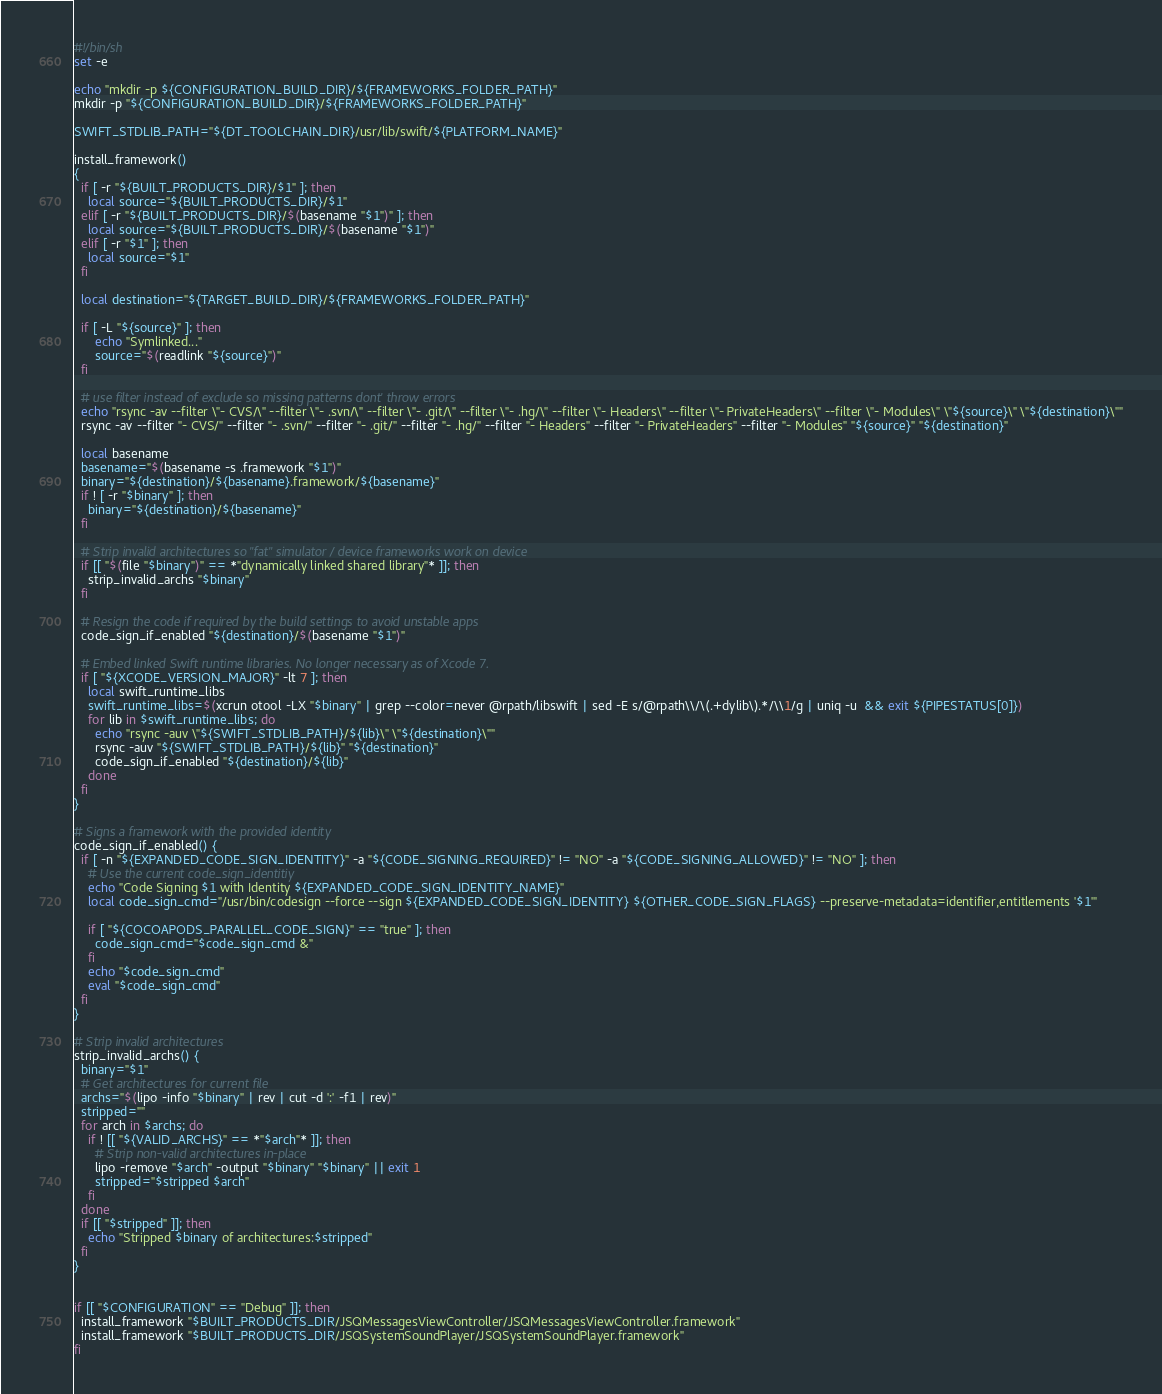<code> <loc_0><loc_0><loc_500><loc_500><_Bash_>#!/bin/sh
set -e

echo "mkdir -p ${CONFIGURATION_BUILD_DIR}/${FRAMEWORKS_FOLDER_PATH}"
mkdir -p "${CONFIGURATION_BUILD_DIR}/${FRAMEWORKS_FOLDER_PATH}"

SWIFT_STDLIB_PATH="${DT_TOOLCHAIN_DIR}/usr/lib/swift/${PLATFORM_NAME}"

install_framework()
{
  if [ -r "${BUILT_PRODUCTS_DIR}/$1" ]; then
    local source="${BUILT_PRODUCTS_DIR}/$1"
  elif [ -r "${BUILT_PRODUCTS_DIR}/$(basename "$1")" ]; then
    local source="${BUILT_PRODUCTS_DIR}/$(basename "$1")"
  elif [ -r "$1" ]; then
    local source="$1"
  fi

  local destination="${TARGET_BUILD_DIR}/${FRAMEWORKS_FOLDER_PATH}"

  if [ -L "${source}" ]; then
      echo "Symlinked..."
      source="$(readlink "${source}")"
  fi

  # use filter instead of exclude so missing patterns dont' throw errors
  echo "rsync -av --filter \"- CVS/\" --filter \"- .svn/\" --filter \"- .git/\" --filter \"- .hg/\" --filter \"- Headers\" --filter \"- PrivateHeaders\" --filter \"- Modules\" \"${source}\" \"${destination}\""
  rsync -av --filter "- CVS/" --filter "- .svn/" --filter "- .git/" --filter "- .hg/" --filter "- Headers" --filter "- PrivateHeaders" --filter "- Modules" "${source}" "${destination}"

  local basename
  basename="$(basename -s .framework "$1")"
  binary="${destination}/${basename}.framework/${basename}"
  if ! [ -r "$binary" ]; then
    binary="${destination}/${basename}"
  fi

  # Strip invalid architectures so "fat" simulator / device frameworks work on device
  if [[ "$(file "$binary")" == *"dynamically linked shared library"* ]]; then
    strip_invalid_archs "$binary"
  fi

  # Resign the code if required by the build settings to avoid unstable apps
  code_sign_if_enabled "${destination}/$(basename "$1")"

  # Embed linked Swift runtime libraries. No longer necessary as of Xcode 7.
  if [ "${XCODE_VERSION_MAJOR}" -lt 7 ]; then
    local swift_runtime_libs
    swift_runtime_libs=$(xcrun otool -LX "$binary" | grep --color=never @rpath/libswift | sed -E s/@rpath\\/\(.+dylib\).*/\\1/g | uniq -u  && exit ${PIPESTATUS[0]})
    for lib in $swift_runtime_libs; do
      echo "rsync -auv \"${SWIFT_STDLIB_PATH}/${lib}\" \"${destination}\""
      rsync -auv "${SWIFT_STDLIB_PATH}/${lib}" "${destination}"
      code_sign_if_enabled "${destination}/${lib}"
    done
  fi
}

# Signs a framework with the provided identity
code_sign_if_enabled() {
  if [ -n "${EXPANDED_CODE_SIGN_IDENTITY}" -a "${CODE_SIGNING_REQUIRED}" != "NO" -a "${CODE_SIGNING_ALLOWED}" != "NO" ]; then
    # Use the current code_sign_identitiy
    echo "Code Signing $1 with Identity ${EXPANDED_CODE_SIGN_IDENTITY_NAME}"
    local code_sign_cmd="/usr/bin/codesign --force --sign ${EXPANDED_CODE_SIGN_IDENTITY} ${OTHER_CODE_SIGN_FLAGS} --preserve-metadata=identifier,entitlements '$1'"

    if [ "${COCOAPODS_PARALLEL_CODE_SIGN}" == "true" ]; then
      code_sign_cmd="$code_sign_cmd &"
    fi
    echo "$code_sign_cmd"
    eval "$code_sign_cmd"
  fi
}

# Strip invalid architectures
strip_invalid_archs() {
  binary="$1"
  # Get architectures for current file
  archs="$(lipo -info "$binary" | rev | cut -d ':' -f1 | rev)"
  stripped=""
  for arch in $archs; do
    if ! [[ "${VALID_ARCHS}" == *"$arch"* ]]; then
      # Strip non-valid architectures in-place
      lipo -remove "$arch" -output "$binary" "$binary" || exit 1
      stripped="$stripped $arch"
    fi
  done
  if [[ "$stripped" ]]; then
    echo "Stripped $binary of architectures:$stripped"
  fi
}


if [[ "$CONFIGURATION" == "Debug" ]]; then
  install_framework "$BUILT_PRODUCTS_DIR/JSQMessagesViewController/JSQMessagesViewController.framework"
  install_framework "$BUILT_PRODUCTS_DIR/JSQSystemSoundPlayer/JSQSystemSoundPlayer.framework"
fi</code> 